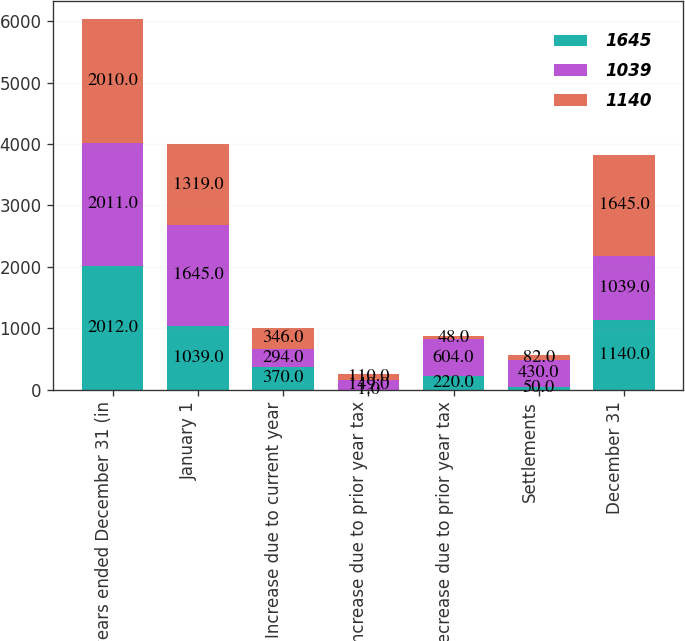Convert chart. <chart><loc_0><loc_0><loc_500><loc_500><stacked_bar_chart><ecel><fcel>years ended December 31 (in<fcel>January 1<fcel>Increase due to current year<fcel>Increase due to prior year tax<fcel>Decrease due to prior year tax<fcel>Settlements<fcel>December 31<nl><fcel>1645<fcel>2012<fcel>1039<fcel>370<fcel>1<fcel>220<fcel>50<fcel>1140<nl><fcel>1039<fcel>2011<fcel>1645<fcel>294<fcel>149<fcel>604<fcel>430<fcel>1039<nl><fcel>1140<fcel>2010<fcel>1319<fcel>346<fcel>110<fcel>48<fcel>82<fcel>1645<nl></chart> 